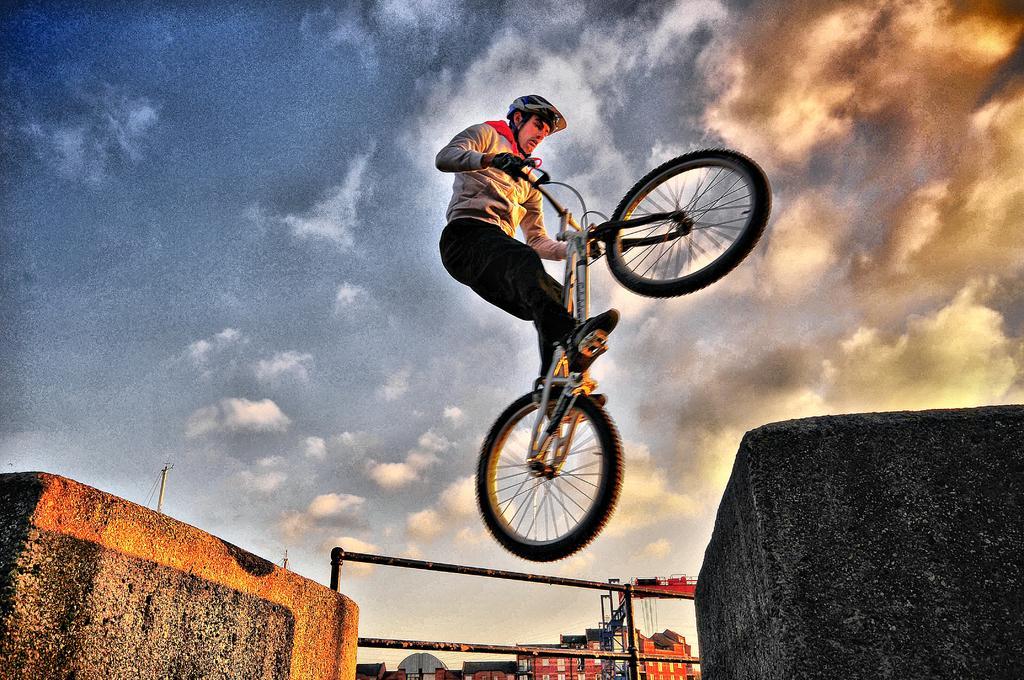In one or two sentences, can you explain what this image depicts? In this image there is a person standing on the bicycle, which is in the air. On the left and right side of the image there are pillars, in the middle of them there is a railing. In the background there are buildings and the sky. 